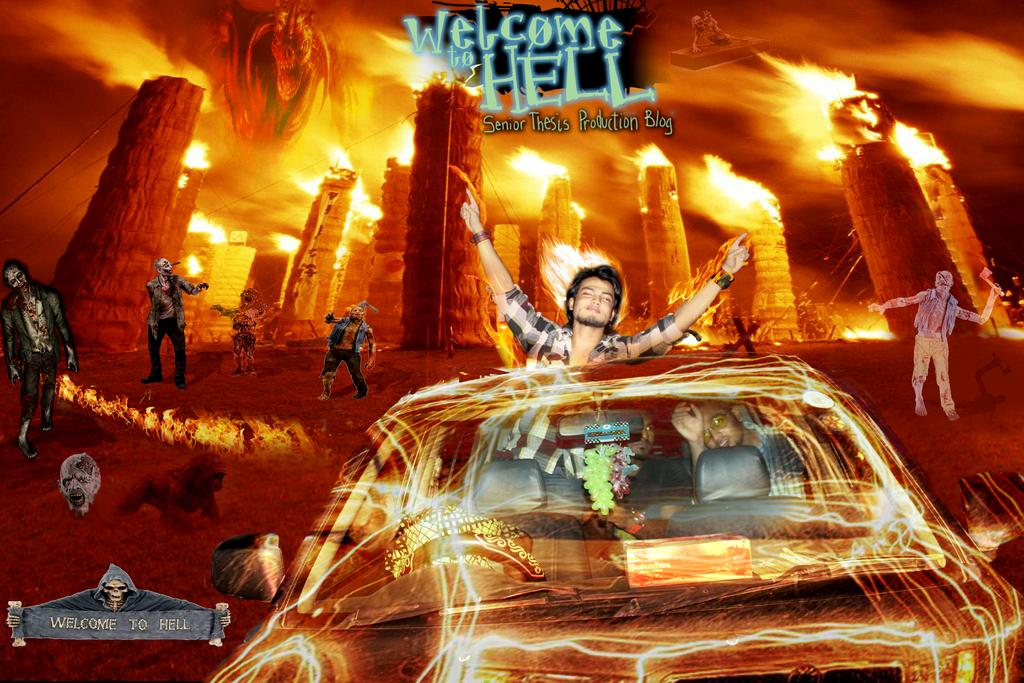<image>
Offer a succinct explanation of the picture presented. A picture of a car is below the title of Welcome To Hell. 